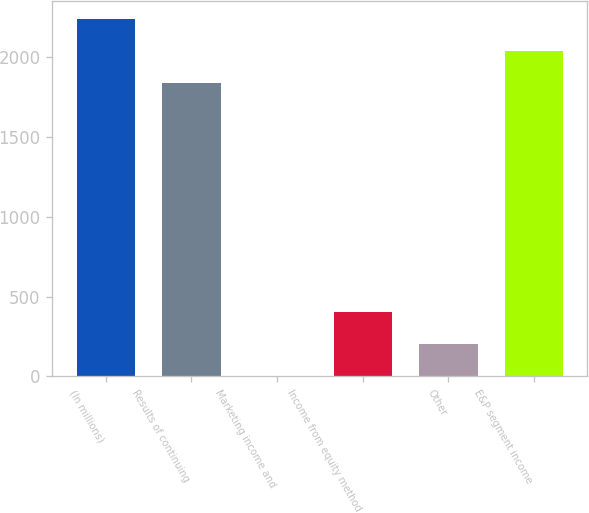Convert chart to OTSL. <chart><loc_0><loc_0><loc_500><loc_500><bar_chart><fcel>(In millions)<fcel>Results of continuing<fcel>Marketing income and<fcel>Income from equity method<fcel>Other<fcel>E&P segment income<nl><fcel>2235.2<fcel>1835<fcel>4<fcel>404.2<fcel>204.1<fcel>2035.1<nl></chart> 